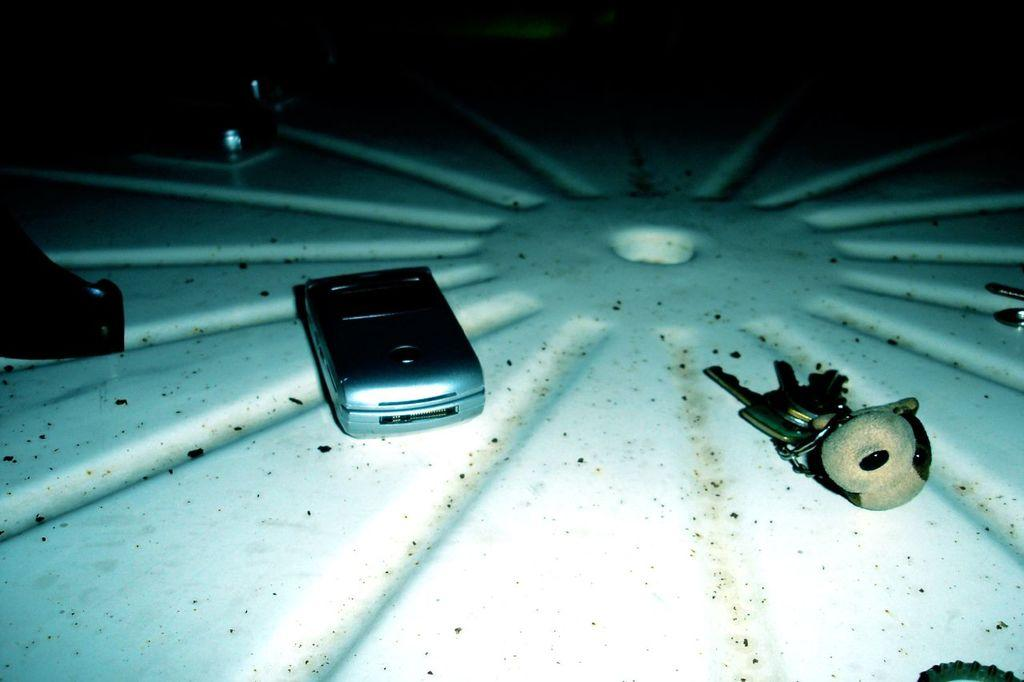What is the main subject in the center of the image? There is a mobile phone in the center of the image. What other items can be seen in the image? There are keys and a key chain in the image. What is the color of the object on which the keys and key chain are placed? The other objects are on a white color object in the image. How would you describe the background of the image? The background of the image is very dark. Is there a volcano erupting in the background of the image? No, there is no volcano or any indication of an eruption in the image. Can you see a loaf of bread on the white object in the image? No, there is no bread present in the image. 